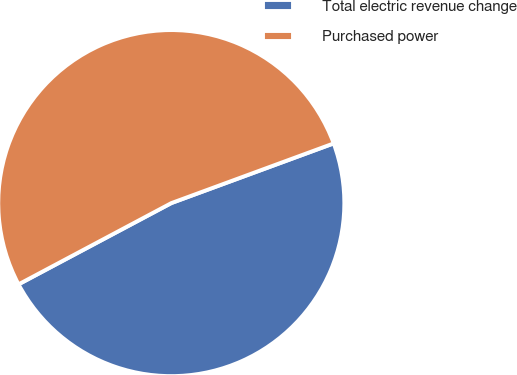Convert chart. <chart><loc_0><loc_0><loc_500><loc_500><pie_chart><fcel>Total electric revenue change<fcel>Purchased power<nl><fcel>47.83%<fcel>52.17%<nl></chart> 